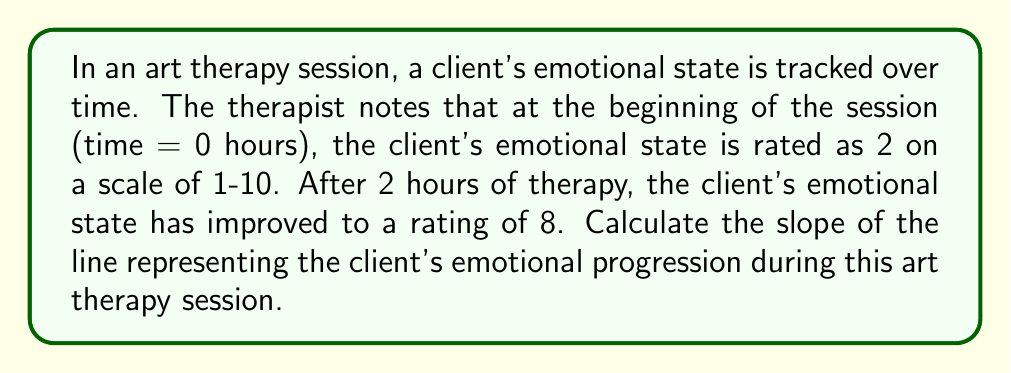Help me with this question. To calculate the slope of the line representing emotional progression, we'll use the slope formula:

$$ m = \frac{y_2 - y_1}{x_2 - x_1} $$

Where:
- $m$ is the slope
- $(x_1, y_1)$ is the initial point
- $(x_2, y_2)$ is the final point

Given:
- Initial point: $(0, 2)$ where $x_1 = 0$ (start time) and $y_1 = 2$ (initial emotional state)
- Final point: $(2, 8)$ where $x_2 = 2$ (2 hours later) and $y_2 = 8$ (final emotional state)

Let's substitute these values into the slope formula:

$$ m = \frac{8 - 2}{2 - 0} $$

$$ m = \frac{6}{2} $$

$$ m = 3 $$

The slope of 3 indicates that for each hour of art therapy, the client's emotional state improved by 3 points on the scale.
Answer: $3$ 